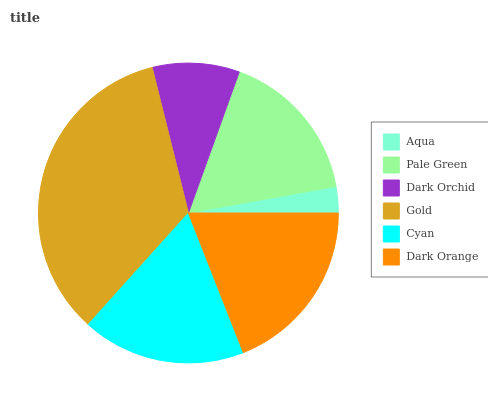Is Aqua the minimum?
Answer yes or no. Yes. Is Gold the maximum?
Answer yes or no. Yes. Is Pale Green the minimum?
Answer yes or no. No. Is Pale Green the maximum?
Answer yes or no. No. Is Pale Green greater than Aqua?
Answer yes or no. Yes. Is Aqua less than Pale Green?
Answer yes or no. Yes. Is Aqua greater than Pale Green?
Answer yes or no. No. Is Pale Green less than Aqua?
Answer yes or no. No. Is Cyan the high median?
Answer yes or no. Yes. Is Pale Green the low median?
Answer yes or no. Yes. Is Aqua the high median?
Answer yes or no. No. Is Cyan the low median?
Answer yes or no. No. 